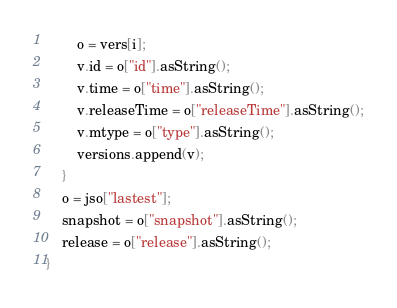Convert code to text. <code><loc_0><loc_0><loc_500><loc_500><_C++_>        o = vers[i];
        v.id = o["id"].asString();
        v.time = o["time"].asString();
        v.releaseTime = o["releaseTime"].asString();
        v.mtype = o["type"].asString();
        versions.append(v);
    }
    o = jso["lastest"];
    snapshot = o["snapshot"].asString();
    release = o["release"].asString();
}
</code> 